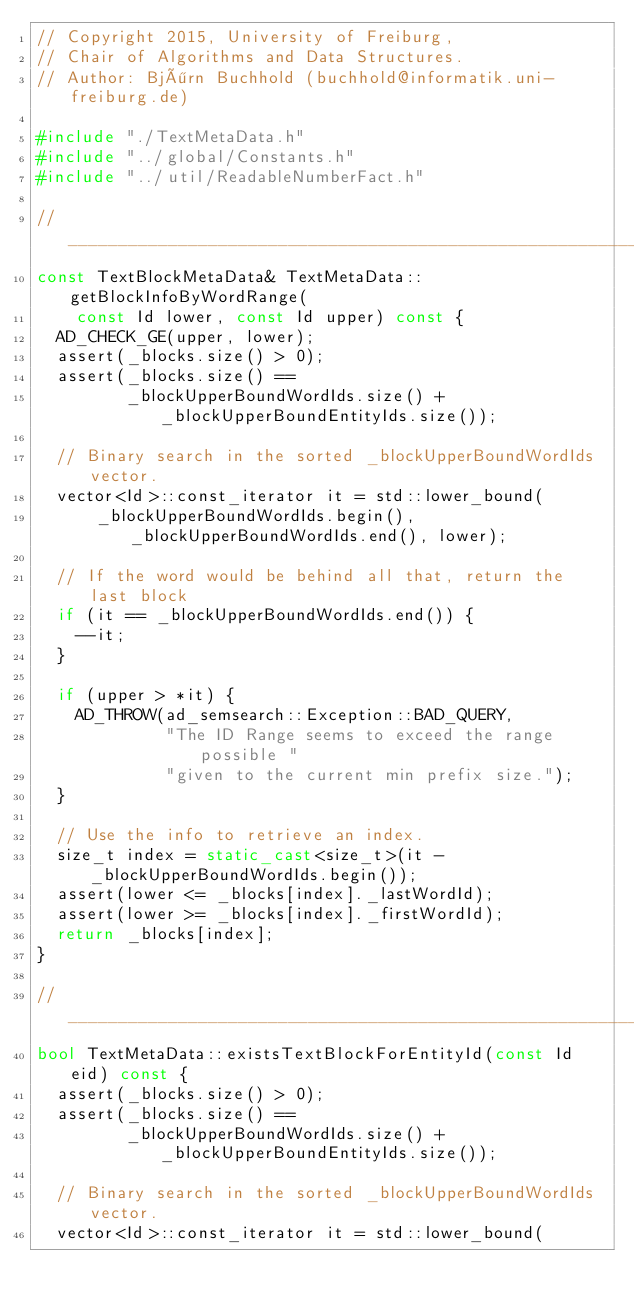Convert code to text. <code><loc_0><loc_0><loc_500><loc_500><_C++_>// Copyright 2015, University of Freiburg,
// Chair of Algorithms and Data Structures.
// Author: Björn Buchhold (buchhold@informatik.uni-freiburg.de)

#include "./TextMetaData.h"
#include "../global/Constants.h"
#include "../util/ReadableNumberFact.h"

// _____________________________________________________________________________
const TextBlockMetaData& TextMetaData::getBlockInfoByWordRange(
    const Id lower, const Id upper) const {
  AD_CHECK_GE(upper, lower);
  assert(_blocks.size() > 0);
  assert(_blocks.size() ==
         _blockUpperBoundWordIds.size() + _blockUpperBoundEntityIds.size());

  // Binary search in the sorted _blockUpperBoundWordIds vector.
  vector<Id>::const_iterator it = std::lower_bound(
      _blockUpperBoundWordIds.begin(), _blockUpperBoundWordIds.end(), lower);

  // If the word would be behind all that, return the last block
  if (it == _blockUpperBoundWordIds.end()) {
    --it;
  }

  if (upper > *it) {
    AD_THROW(ad_semsearch::Exception::BAD_QUERY,
             "The ID Range seems to exceed the range possible "
             "given to the current min prefix size.");
  }

  // Use the info to retrieve an index.
  size_t index = static_cast<size_t>(it - _blockUpperBoundWordIds.begin());
  assert(lower <= _blocks[index]._lastWordId);
  assert(lower >= _blocks[index]._firstWordId);
  return _blocks[index];
}

// _____________________________________________________________________________
bool TextMetaData::existsTextBlockForEntityId(const Id eid) const {
  assert(_blocks.size() > 0);
  assert(_blocks.size() ==
         _blockUpperBoundWordIds.size() + _blockUpperBoundEntityIds.size());

  // Binary search in the sorted _blockUpperBoundWordIds vector.
  vector<Id>::const_iterator it = std::lower_bound(</code> 